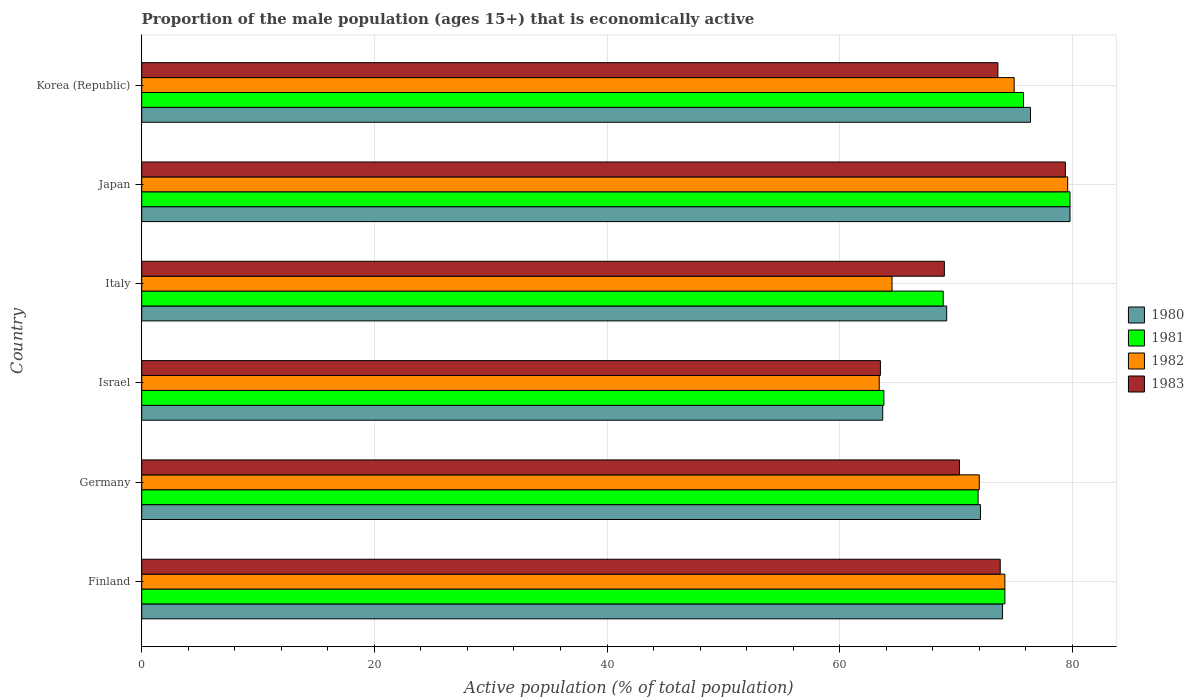How many different coloured bars are there?
Your response must be concise. 4. Are the number of bars per tick equal to the number of legend labels?
Keep it short and to the point. Yes. Are the number of bars on each tick of the Y-axis equal?
Your answer should be very brief. Yes. How many bars are there on the 2nd tick from the top?
Provide a succinct answer. 4. How many bars are there on the 6th tick from the bottom?
Your answer should be compact. 4. What is the label of the 2nd group of bars from the top?
Make the answer very short. Japan. In how many cases, is the number of bars for a given country not equal to the number of legend labels?
Your response must be concise. 0. What is the proportion of the male population that is economically active in 1980 in Japan?
Offer a very short reply. 79.8. Across all countries, what is the maximum proportion of the male population that is economically active in 1982?
Make the answer very short. 79.6. Across all countries, what is the minimum proportion of the male population that is economically active in 1980?
Offer a terse response. 63.7. What is the total proportion of the male population that is economically active in 1983 in the graph?
Keep it short and to the point. 429.6. What is the difference between the proportion of the male population that is economically active in 1981 in Finland and that in Germany?
Provide a succinct answer. 2.3. What is the difference between the proportion of the male population that is economically active in 1980 in Japan and the proportion of the male population that is economically active in 1983 in Israel?
Offer a very short reply. 16.3. What is the average proportion of the male population that is economically active in 1982 per country?
Provide a short and direct response. 71.45. What is the difference between the proportion of the male population that is economically active in 1981 and proportion of the male population that is economically active in 1983 in Israel?
Give a very brief answer. 0.3. In how many countries, is the proportion of the male population that is economically active in 1980 greater than 56 %?
Your answer should be compact. 6. What is the ratio of the proportion of the male population that is economically active in 1983 in Germany to that in Japan?
Your answer should be very brief. 0.89. What is the difference between the highest and the second highest proportion of the male population that is economically active in 1982?
Provide a short and direct response. 4.6. What is the difference between the highest and the lowest proportion of the male population that is economically active in 1981?
Your answer should be compact. 16. What does the 4th bar from the top in Finland represents?
Offer a very short reply. 1980. Are all the bars in the graph horizontal?
Your answer should be compact. Yes. How many countries are there in the graph?
Your response must be concise. 6. What is the difference between two consecutive major ticks on the X-axis?
Give a very brief answer. 20. Are the values on the major ticks of X-axis written in scientific E-notation?
Give a very brief answer. No. Does the graph contain grids?
Keep it short and to the point. Yes. Where does the legend appear in the graph?
Your answer should be compact. Center right. How many legend labels are there?
Your answer should be very brief. 4. What is the title of the graph?
Offer a terse response. Proportion of the male population (ages 15+) that is economically active. What is the label or title of the X-axis?
Your response must be concise. Active population (% of total population). What is the label or title of the Y-axis?
Your response must be concise. Country. What is the Active population (% of total population) of 1981 in Finland?
Offer a terse response. 74.2. What is the Active population (% of total population) in 1982 in Finland?
Make the answer very short. 74.2. What is the Active population (% of total population) in 1983 in Finland?
Your response must be concise. 73.8. What is the Active population (% of total population) of 1980 in Germany?
Keep it short and to the point. 72.1. What is the Active population (% of total population) of 1981 in Germany?
Give a very brief answer. 71.9. What is the Active population (% of total population) in 1983 in Germany?
Provide a short and direct response. 70.3. What is the Active population (% of total population) of 1980 in Israel?
Offer a very short reply. 63.7. What is the Active population (% of total population) of 1981 in Israel?
Your answer should be compact. 63.8. What is the Active population (% of total population) in 1982 in Israel?
Offer a terse response. 63.4. What is the Active population (% of total population) of 1983 in Israel?
Keep it short and to the point. 63.5. What is the Active population (% of total population) in 1980 in Italy?
Make the answer very short. 69.2. What is the Active population (% of total population) of 1981 in Italy?
Keep it short and to the point. 68.9. What is the Active population (% of total population) of 1982 in Italy?
Offer a very short reply. 64.5. What is the Active population (% of total population) of 1983 in Italy?
Keep it short and to the point. 69. What is the Active population (% of total population) in 1980 in Japan?
Your answer should be very brief. 79.8. What is the Active population (% of total population) of 1981 in Japan?
Ensure brevity in your answer.  79.8. What is the Active population (% of total population) in 1982 in Japan?
Your answer should be compact. 79.6. What is the Active population (% of total population) of 1983 in Japan?
Provide a succinct answer. 79.4. What is the Active population (% of total population) of 1980 in Korea (Republic)?
Your answer should be very brief. 76.4. What is the Active population (% of total population) in 1981 in Korea (Republic)?
Your answer should be compact. 75.8. What is the Active population (% of total population) in 1982 in Korea (Republic)?
Offer a terse response. 75. What is the Active population (% of total population) of 1983 in Korea (Republic)?
Make the answer very short. 73.6. Across all countries, what is the maximum Active population (% of total population) in 1980?
Offer a terse response. 79.8. Across all countries, what is the maximum Active population (% of total population) of 1981?
Offer a terse response. 79.8. Across all countries, what is the maximum Active population (% of total population) in 1982?
Your answer should be very brief. 79.6. Across all countries, what is the maximum Active population (% of total population) of 1983?
Your response must be concise. 79.4. Across all countries, what is the minimum Active population (% of total population) in 1980?
Your response must be concise. 63.7. Across all countries, what is the minimum Active population (% of total population) of 1981?
Provide a succinct answer. 63.8. Across all countries, what is the minimum Active population (% of total population) in 1982?
Give a very brief answer. 63.4. Across all countries, what is the minimum Active population (% of total population) in 1983?
Offer a terse response. 63.5. What is the total Active population (% of total population) of 1980 in the graph?
Your answer should be compact. 435.2. What is the total Active population (% of total population) of 1981 in the graph?
Your answer should be compact. 434.4. What is the total Active population (% of total population) in 1982 in the graph?
Give a very brief answer. 428.7. What is the total Active population (% of total population) in 1983 in the graph?
Offer a terse response. 429.6. What is the difference between the Active population (% of total population) in 1980 in Finland and that in Germany?
Make the answer very short. 1.9. What is the difference between the Active population (% of total population) of 1981 in Finland and that in Germany?
Keep it short and to the point. 2.3. What is the difference between the Active population (% of total population) in 1980 in Finland and that in Israel?
Keep it short and to the point. 10.3. What is the difference between the Active population (% of total population) of 1982 in Finland and that in Israel?
Your answer should be compact. 10.8. What is the difference between the Active population (% of total population) of 1982 in Finland and that in Italy?
Your answer should be compact. 9.7. What is the difference between the Active population (% of total population) in 1981 in Finland and that in Japan?
Keep it short and to the point. -5.6. What is the difference between the Active population (% of total population) of 1982 in Finland and that in Japan?
Your answer should be very brief. -5.4. What is the difference between the Active population (% of total population) of 1983 in Finland and that in Japan?
Make the answer very short. -5.6. What is the difference between the Active population (% of total population) of 1981 in Finland and that in Korea (Republic)?
Your answer should be compact. -1.6. What is the difference between the Active population (% of total population) of 1981 in Germany and that in Israel?
Your answer should be compact. 8.1. What is the difference between the Active population (% of total population) of 1983 in Germany and that in Israel?
Give a very brief answer. 6.8. What is the difference between the Active population (% of total population) in 1980 in Germany and that in Italy?
Your response must be concise. 2.9. What is the difference between the Active population (% of total population) in 1981 in Germany and that in Italy?
Ensure brevity in your answer.  3. What is the difference between the Active population (% of total population) of 1983 in Germany and that in Italy?
Your answer should be compact. 1.3. What is the difference between the Active population (% of total population) in 1980 in Germany and that in Japan?
Offer a very short reply. -7.7. What is the difference between the Active population (% of total population) of 1982 in Germany and that in Korea (Republic)?
Offer a very short reply. -3. What is the difference between the Active population (% of total population) of 1980 in Israel and that in Italy?
Provide a succinct answer. -5.5. What is the difference between the Active population (% of total population) of 1981 in Israel and that in Italy?
Provide a short and direct response. -5.1. What is the difference between the Active population (% of total population) in 1980 in Israel and that in Japan?
Provide a succinct answer. -16.1. What is the difference between the Active population (% of total population) of 1982 in Israel and that in Japan?
Keep it short and to the point. -16.2. What is the difference between the Active population (% of total population) of 1983 in Israel and that in Japan?
Offer a terse response. -15.9. What is the difference between the Active population (% of total population) of 1981 in Israel and that in Korea (Republic)?
Your answer should be compact. -12. What is the difference between the Active population (% of total population) of 1982 in Israel and that in Korea (Republic)?
Make the answer very short. -11.6. What is the difference between the Active population (% of total population) of 1980 in Italy and that in Japan?
Make the answer very short. -10.6. What is the difference between the Active population (% of total population) of 1982 in Italy and that in Japan?
Make the answer very short. -15.1. What is the difference between the Active population (% of total population) in 1980 in Italy and that in Korea (Republic)?
Provide a succinct answer. -7.2. What is the difference between the Active population (% of total population) in 1981 in Italy and that in Korea (Republic)?
Provide a succinct answer. -6.9. What is the difference between the Active population (% of total population) in 1982 in Italy and that in Korea (Republic)?
Your answer should be compact. -10.5. What is the difference between the Active population (% of total population) in 1982 in Japan and that in Korea (Republic)?
Ensure brevity in your answer.  4.6. What is the difference between the Active population (% of total population) of 1980 in Finland and the Active population (% of total population) of 1981 in Germany?
Offer a very short reply. 2.1. What is the difference between the Active population (% of total population) of 1980 in Finland and the Active population (% of total population) of 1982 in Germany?
Provide a succinct answer. 2. What is the difference between the Active population (% of total population) of 1982 in Finland and the Active population (% of total population) of 1983 in Germany?
Make the answer very short. 3.9. What is the difference between the Active population (% of total population) in 1980 in Finland and the Active population (% of total population) in 1982 in Israel?
Give a very brief answer. 10.6. What is the difference between the Active population (% of total population) of 1982 in Finland and the Active population (% of total population) of 1983 in Israel?
Keep it short and to the point. 10.7. What is the difference between the Active population (% of total population) of 1980 in Finland and the Active population (% of total population) of 1981 in Italy?
Ensure brevity in your answer.  5.1. What is the difference between the Active population (% of total population) in 1980 in Finland and the Active population (% of total population) in 1982 in Italy?
Your response must be concise. 9.5. What is the difference between the Active population (% of total population) in 1980 in Finland and the Active population (% of total population) in 1983 in Italy?
Offer a terse response. 5. What is the difference between the Active population (% of total population) in 1980 in Finland and the Active population (% of total population) in 1982 in Japan?
Your answer should be very brief. -5.6. What is the difference between the Active population (% of total population) of 1981 in Finland and the Active population (% of total population) of 1982 in Japan?
Give a very brief answer. -5.4. What is the difference between the Active population (% of total population) of 1981 in Finland and the Active population (% of total population) of 1983 in Japan?
Provide a succinct answer. -5.2. What is the difference between the Active population (% of total population) in 1980 in Finland and the Active population (% of total population) in 1983 in Korea (Republic)?
Offer a very short reply. 0.4. What is the difference between the Active population (% of total population) in 1981 in Finland and the Active population (% of total population) in 1982 in Korea (Republic)?
Your response must be concise. -0.8. What is the difference between the Active population (% of total population) of 1980 in Germany and the Active population (% of total population) of 1981 in Israel?
Your answer should be compact. 8.3. What is the difference between the Active population (% of total population) in 1980 in Germany and the Active population (% of total population) in 1983 in Israel?
Ensure brevity in your answer.  8.6. What is the difference between the Active population (% of total population) in 1982 in Germany and the Active population (% of total population) in 1983 in Israel?
Give a very brief answer. 8.5. What is the difference between the Active population (% of total population) in 1980 in Germany and the Active population (% of total population) in 1981 in Italy?
Keep it short and to the point. 3.2. What is the difference between the Active population (% of total population) of 1980 in Germany and the Active population (% of total population) of 1982 in Italy?
Offer a very short reply. 7.6. What is the difference between the Active population (% of total population) in 1980 in Germany and the Active population (% of total population) in 1983 in Italy?
Give a very brief answer. 3.1. What is the difference between the Active population (% of total population) in 1981 in Germany and the Active population (% of total population) in 1983 in Italy?
Ensure brevity in your answer.  2.9. What is the difference between the Active population (% of total population) in 1982 in Germany and the Active population (% of total population) in 1983 in Italy?
Offer a terse response. 3. What is the difference between the Active population (% of total population) of 1981 in Germany and the Active population (% of total population) of 1983 in Japan?
Provide a succinct answer. -7.5. What is the difference between the Active population (% of total population) of 1982 in Germany and the Active population (% of total population) of 1983 in Japan?
Your answer should be very brief. -7.4. What is the difference between the Active population (% of total population) of 1981 in Germany and the Active population (% of total population) of 1983 in Korea (Republic)?
Offer a terse response. -1.7. What is the difference between the Active population (% of total population) of 1982 in Germany and the Active population (% of total population) of 1983 in Korea (Republic)?
Give a very brief answer. -1.6. What is the difference between the Active population (% of total population) of 1980 in Israel and the Active population (% of total population) of 1982 in Italy?
Keep it short and to the point. -0.8. What is the difference between the Active population (% of total population) of 1981 in Israel and the Active population (% of total population) of 1983 in Italy?
Provide a succinct answer. -5.2. What is the difference between the Active population (% of total population) in 1982 in Israel and the Active population (% of total population) in 1983 in Italy?
Keep it short and to the point. -5.6. What is the difference between the Active population (% of total population) of 1980 in Israel and the Active population (% of total population) of 1981 in Japan?
Offer a terse response. -16.1. What is the difference between the Active population (% of total population) of 1980 in Israel and the Active population (% of total population) of 1982 in Japan?
Provide a succinct answer. -15.9. What is the difference between the Active population (% of total population) in 1980 in Israel and the Active population (% of total population) in 1983 in Japan?
Offer a very short reply. -15.7. What is the difference between the Active population (% of total population) of 1981 in Israel and the Active population (% of total population) of 1982 in Japan?
Offer a terse response. -15.8. What is the difference between the Active population (% of total population) in 1981 in Israel and the Active population (% of total population) in 1983 in Japan?
Provide a short and direct response. -15.6. What is the difference between the Active population (% of total population) in 1980 in Israel and the Active population (% of total population) in 1981 in Korea (Republic)?
Keep it short and to the point. -12.1. What is the difference between the Active population (% of total population) of 1980 in Israel and the Active population (% of total population) of 1982 in Korea (Republic)?
Offer a very short reply. -11.3. What is the difference between the Active population (% of total population) in 1980 in Israel and the Active population (% of total population) in 1983 in Korea (Republic)?
Provide a short and direct response. -9.9. What is the difference between the Active population (% of total population) of 1981 in Israel and the Active population (% of total population) of 1983 in Korea (Republic)?
Offer a terse response. -9.8. What is the difference between the Active population (% of total population) in 1980 in Italy and the Active population (% of total population) in 1983 in Japan?
Your answer should be very brief. -10.2. What is the difference between the Active population (% of total population) of 1982 in Italy and the Active population (% of total population) of 1983 in Japan?
Provide a short and direct response. -14.9. What is the difference between the Active population (% of total population) of 1980 in Italy and the Active population (% of total population) of 1981 in Korea (Republic)?
Give a very brief answer. -6.6. What is the difference between the Active population (% of total population) in 1980 in Italy and the Active population (% of total population) in 1983 in Korea (Republic)?
Give a very brief answer. -4.4. What is the difference between the Active population (% of total population) in 1981 in Italy and the Active population (% of total population) in 1983 in Korea (Republic)?
Ensure brevity in your answer.  -4.7. What is the difference between the Active population (% of total population) of 1982 in Italy and the Active population (% of total population) of 1983 in Korea (Republic)?
Offer a terse response. -9.1. What is the difference between the Active population (% of total population) of 1980 in Japan and the Active population (% of total population) of 1981 in Korea (Republic)?
Provide a succinct answer. 4. What is the difference between the Active population (% of total population) of 1982 in Japan and the Active population (% of total population) of 1983 in Korea (Republic)?
Offer a very short reply. 6. What is the average Active population (% of total population) of 1980 per country?
Ensure brevity in your answer.  72.53. What is the average Active population (% of total population) of 1981 per country?
Offer a very short reply. 72.4. What is the average Active population (% of total population) in 1982 per country?
Provide a short and direct response. 71.45. What is the average Active population (% of total population) in 1983 per country?
Provide a succinct answer. 71.6. What is the difference between the Active population (% of total population) of 1980 and Active population (% of total population) of 1981 in Finland?
Your answer should be compact. -0.2. What is the difference between the Active population (% of total population) in 1981 and Active population (% of total population) in 1983 in Finland?
Your answer should be compact. 0.4. What is the difference between the Active population (% of total population) in 1982 and Active population (% of total population) in 1983 in Finland?
Make the answer very short. 0.4. What is the difference between the Active population (% of total population) of 1980 and Active population (% of total population) of 1981 in Germany?
Give a very brief answer. 0.2. What is the difference between the Active population (% of total population) in 1982 and Active population (% of total population) in 1983 in Germany?
Provide a short and direct response. 1.7. What is the difference between the Active population (% of total population) of 1980 and Active population (% of total population) of 1981 in Israel?
Your response must be concise. -0.1. What is the difference between the Active population (% of total population) in 1980 and Active population (% of total population) in 1983 in Israel?
Provide a succinct answer. 0.2. What is the difference between the Active population (% of total population) in 1980 and Active population (% of total population) in 1982 in Italy?
Your answer should be very brief. 4.7. What is the difference between the Active population (% of total population) in 1980 and Active population (% of total population) in 1983 in Italy?
Keep it short and to the point. 0.2. What is the difference between the Active population (% of total population) in 1981 and Active population (% of total population) in 1982 in Italy?
Offer a very short reply. 4.4. What is the difference between the Active population (% of total population) in 1980 and Active population (% of total population) in 1982 in Japan?
Provide a short and direct response. 0.2. What is the difference between the Active population (% of total population) in 1980 and Active population (% of total population) in 1983 in Japan?
Keep it short and to the point. 0.4. What is the difference between the Active population (% of total population) in 1981 and Active population (% of total population) in 1983 in Japan?
Provide a short and direct response. 0.4. What is the difference between the Active population (% of total population) in 1982 and Active population (% of total population) in 1983 in Japan?
Ensure brevity in your answer.  0.2. What is the difference between the Active population (% of total population) in 1980 and Active population (% of total population) in 1982 in Korea (Republic)?
Give a very brief answer. 1.4. What is the difference between the Active population (% of total population) of 1980 and Active population (% of total population) of 1983 in Korea (Republic)?
Your answer should be very brief. 2.8. What is the difference between the Active population (% of total population) in 1981 and Active population (% of total population) in 1983 in Korea (Republic)?
Keep it short and to the point. 2.2. What is the difference between the Active population (% of total population) in 1982 and Active population (% of total population) in 1983 in Korea (Republic)?
Offer a very short reply. 1.4. What is the ratio of the Active population (% of total population) of 1980 in Finland to that in Germany?
Make the answer very short. 1.03. What is the ratio of the Active population (% of total population) of 1981 in Finland to that in Germany?
Offer a terse response. 1.03. What is the ratio of the Active population (% of total population) in 1982 in Finland to that in Germany?
Your answer should be very brief. 1.03. What is the ratio of the Active population (% of total population) of 1983 in Finland to that in Germany?
Offer a terse response. 1.05. What is the ratio of the Active population (% of total population) of 1980 in Finland to that in Israel?
Give a very brief answer. 1.16. What is the ratio of the Active population (% of total population) in 1981 in Finland to that in Israel?
Ensure brevity in your answer.  1.16. What is the ratio of the Active population (% of total population) in 1982 in Finland to that in Israel?
Provide a succinct answer. 1.17. What is the ratio of the Active population (% of total population) in 1983 in Finland to that in Israel?
Ensure brevity in your answer.  1.16. What is the ratio of the Active population (% of total population) of 1980 in Finland to that in Italy?
Your answer should be very brief. 1.07. What is the ratio of the Active population (% of total population) of 1982 in Finland to that in Italy?
Offer a very short reply. 1.15. What is the ratio of the Active population (% of total population) in 1983 in Finland to that in Italy?
Your answer should be compact. 1.07. What is the ratio of the Active population (% of total population) in 1980 in Finland to that in Japan?
Make the answer very short. 0.93. What is the ratio of the Active population (% of total population) of 1981 in Finland to that in Japan?
Your response must be concise. 0.93. What is the ratio of the Active population (% of total population) in 1982 in Finland to that in Japan?
Make the answer very short. 0.93. What is the ratio of the Active population (% of total population) in 1983 in Finland to that in Japan?
Your response must be concise. 0.93. What is the ratio of the Active population (% of total population) of 1980 in Finland to that in Korea (Republic)?
Offer a terse response. 0.97. What is the ratio of the Active population (% of total population) in 1981 in Finland to that in Korea (Republic)?
Offer a very short reply. 0.98. What is the ratio of the Active population (% of total population) of 1982 in Finland to that in Korea (Republic)?
Your answer should be compact. 0.99. What is the ratio of the Active population (% of total population) in 1983 in Finland to that in Korea (Republic)?
Provide a succinct answer. 1. What is the ratio of the Active population (% of total population) in 1980 in Germany to that in Israel?
Make the answer very short. 1.13. What is the ratio of the Active population (% of total population) in 1981 in Germany to that in Israel?
Your answer should be very brief. 1.13. What is the ratio of the Active population (% of total population) of 1982 in Germany to that in Israel?
Ensure brevity in your answer.  1.14. What is the ratio of the Active population (% of total population) in 1983 in Germany to that in Israel?
Provide a succinct answer. 1.11. What is the ratio of the Active population (% of total population) in 1980 in Germany to that in Italy?
Keep it short and to the point. 1.04. What is the ratio of the Active population (% of total population) in 1981 in Germany to that in Italy?
Your answer should be very brief. 1.04. What is the ratio of the Active population (% of total population) of 1982 in Germany to that in Italy?
Give a very brief answer. 1.12. What is the ratio of the Active population (% of total population) of 1983 in Germany to that in Italy?
Your answer should be compact. 1.02. What is the ratio of the Active population (% of total population) of 1980 in Germany to that in Japan?
Give a very brief answer. 0.9. What is the ratio of the Active population (% of total population) of 1981 in Germany to that in Japan?
Provide a succinct answer. 0.9. What is the ratio of the Active population (% of total population) in 1982 in Germany to that in Japan?
Your answer should be compact. 0.9. What is the ratio of the Active population (% of total population) of 1983 in Germany to that in Japan?
Offer a terse response. 0.89. What is the ratio of the Active population (% of total population) of 1980 in Germany to that in Korea (Republic)?
Your answer should be very brief. 0.94. What is the ratio of the Active population (% of total population) of 1981 in Germany to that in Korea (Republic)?
Make the answer very short. 0.95. What is the ratio of the Active population (% of total population) in 1982 in Germany to that in Korea (Republic)?
Give a very brief answer. 0.96. What is the ratio of the Active population (% of total population) of 1983 in Germany to that in Korea (Republic)?
Make the answer very short. 0.96. What is the ratio of the Active population (% of total population) in 1980 in Israel to that in Italy?
Keep it short and to the point. 0.92. What is the ratio of the Active population (% of total population) of 1981 in Israel to that in Italy?
Provide a succinct answer. 0.93. What is the ratio of the Active population (% of total population) in 1982 in Israel to that in Italy?
Your response must be concise. 0.98. What is the ratio of the Active population (% of total population) in 1983 in Israel to that in Italy?
Provide a succinct answer. 0.92. What is the ratio of the Active population (% of total population) in 1980 in Israel to that in Japan?
Offer a terse response. 0.8. What is the ratio of the Active population (% of total population) in 1981 in Israel to that in Japan?
Offer a very short reply. 0.8. What is the ratio of the Active population (% of total population) of 1982 in Israel to that in Japan?
Your response must be concise. 0.8. What is the ratio of the Active population (% of total population) in 1983 in Israel to that in Japan?
Your answer should be very brief. 0.8. What is the ratio of the Active population (% of total population) of 1980 in Israel to that in Korea (Republic)?
Ensure brevity in your answer.  0.83. What is the ratio of the Active population (% of total population) in 1981 in Israel to that in Korea (Republic)?
Offer a terse response. 0.84. What is the ratio of the Active population (% of total population) in 1982 in Israel to that in Korea (Republic)?
Your response must be concise. 0.85. What is the ratio of the Active population (% of total population) in 1983 in Israel to that in Korea (Republic)?
Provide a succinct answer. 0.86. What is the ratio of the Active population (% of total population) of 1980 in Italy to that in Japan?
Provide a short and direct response. 0.87. What is the ratio of the Active population (% of total population) of 1981 in Italy to that in Japan?
Keep it short and to the point. 0.86. What is the ratio of the Active population (% of total population) in 1982 in Italy to that in Japan?
Your answer should be very brief. 0.81. What is the ratio of the Active population (% of total population) of 1983 in Italy to that in Japan?
Make the answer very short. 0.87. What is the ratio of the Active population (% of total population) of 1980 in Italy to that in Korea (Republic)?
Offer a terse response. 0.91. What is the ratio of the Active population (% of total population) in 1981 in Italy to that in Korea (Republic)?
Offer a very short reply. 0.91. What is the ratio of the Active population (% of total population) in 1982 in Italy to that in Korea (Republic)?
Your response must be concise. 0.86. What is the ratio of the Active population (% of total population) of 1983 in Italy to that in Korea (Republic)?
Provide a short and direct response. 0.94. What is the ratio of the Active population (% of total population) in 1980 in Japan to that in Korea (Republic)?
Make the answer very short. 1.04. What is the ratio of the Active population (% of total population) in 1981 in Japan to that in Korea (Republic)?
Make the answer very short. 1.05. What is the ratio of the Active population (% of total population) of 1982 in Japan to that in Korea (Republic)?
Make the answer very short. 1.06. What is the ratio of the Active population (% of total population) in 1983 in Japan to that in Korea (Republic)?
Provide a short and direct response. 1.08. What is the difference between the highest and the second highest Active population (% of total population) in 1981?
Your response must be concise. 4. What is the difference between the highest and the second highest Active population (% of total population) of 1982?
Offer a very short reply. 4.6. What is the difference between the highest and the second highest Active population (% of total population) in 1983?
Your answer should be compact. 5.6. What is the difference between the highest and the lowest Active population (% of total population) in 1981?
Offer a terse response. 16. What is the difference between the highest and the lowest Active population (% of total population) in 1982?
Offer a terse response. 16.2. What is the difference between the highest and the lowest Active population (% of total population) in 1983?
Your answer should be very brief. 15.9. 